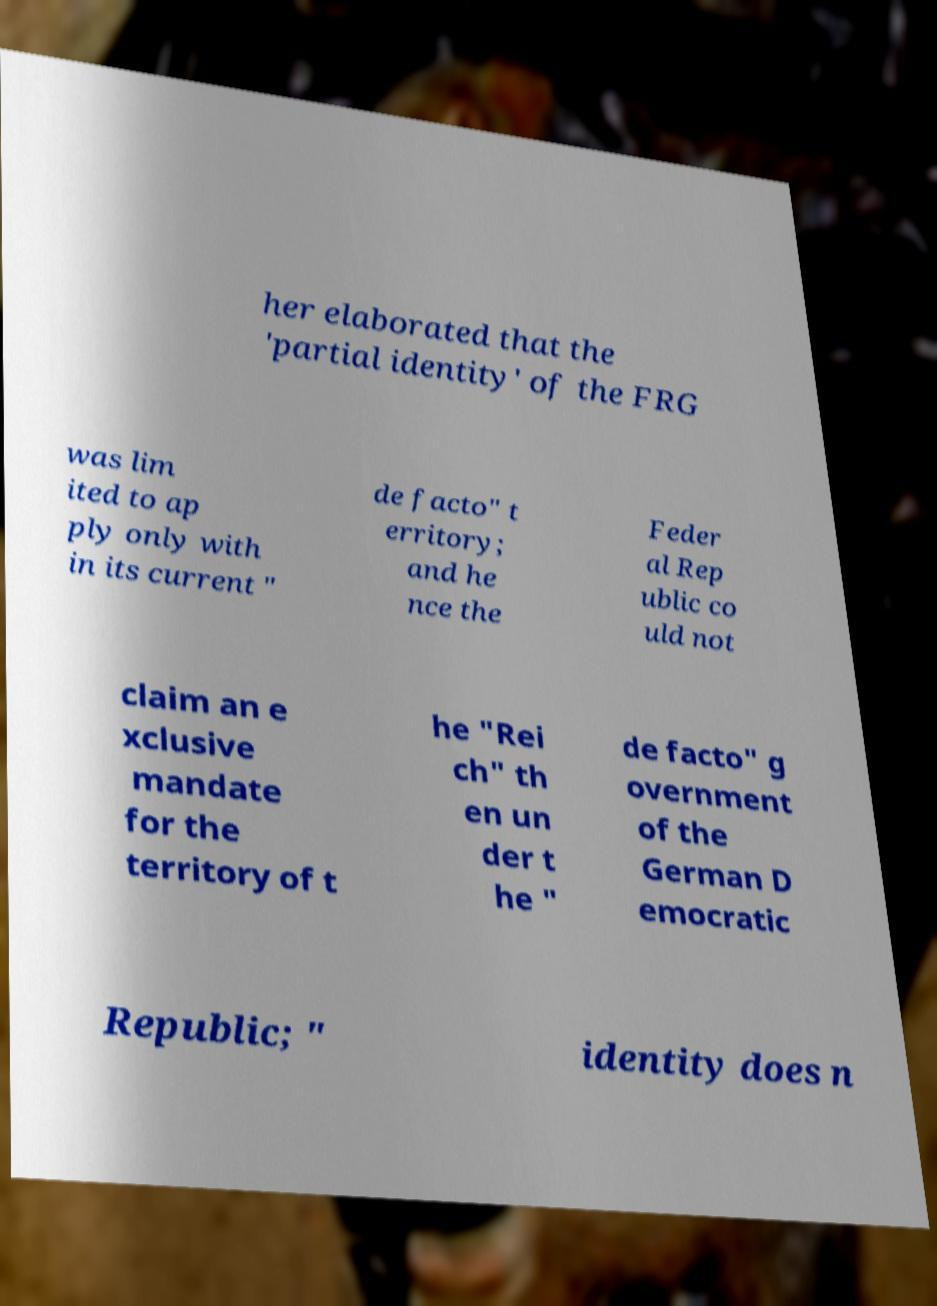Could you extract and type out the text from this image? her elaborated that the 'partial identity' of the FRG was lim ited to ap ply only with in its current " de facto" t erritory; and he nce the Feder al Rep ublic co uld not claim an e xclusive mandate for the territory of t he "Rei ch" th en un der t he " de facto" g overnment of the German D emocratic Republic; " identity does n 